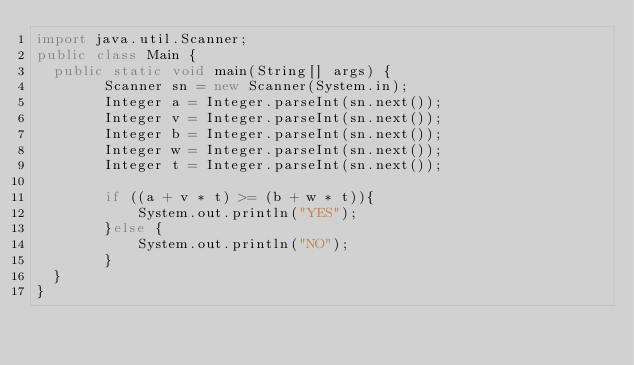Convert code to text. <code><loc_0><loc_0><loc_500><loc_500><_Java_>import java.util.Scanner;
public class Main {
	public static void main(String[] args) {
        Scanner sn = new Scanner(System.in);
        Integer a = Integer.parseInt(sn.next());
        Integer v = Integer.parseInt(sn.next());
        Integer b = Integer.parseInt(sn.next());
        Integer w = Integer.parseInt(sn.next());
        Integer t = Integer.parseInt(sn.next());

        if ((a + v * t) >= (b + w * t)){
            System.out.println("YES");
        }else {
            System.out.println("NO");
        }
	}
}

</code> 